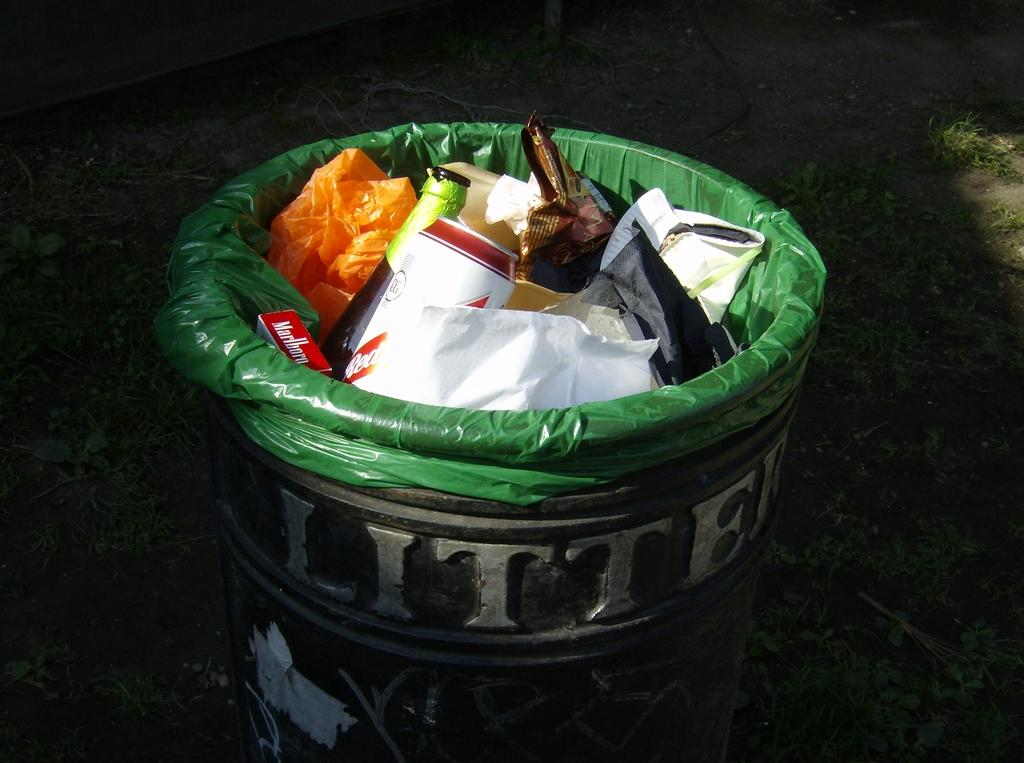Provide a one-sentence caption for the provided image. Litter trash can with a green bag with trash on the inside. 